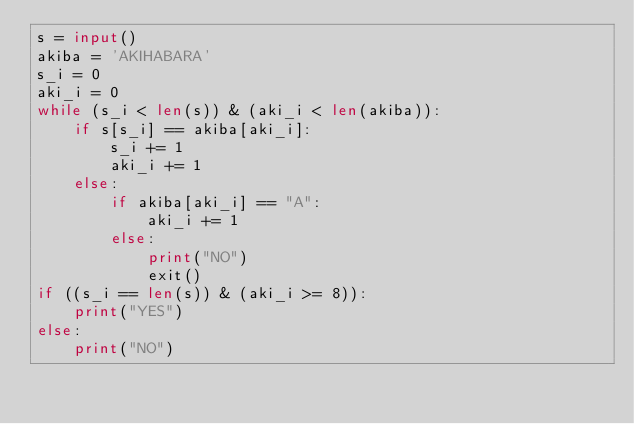Convert code to text. <code><loc_0><loc_0><loc_500><loc_500><_Python_>s = input()
akiba = 'AKIHABARA'
s_i = 0
aki_i = 0
while (s_i < len(s)) & (aki_i < len(akiba)):
    if s[s_i] == akiba[aki_i]:
        s_i += 1
        aki_i += 1
    else:
        if akiba[aki_i] == "A":
            aki_i += 1
        else:
            print("NO")
            exit()
if ((s_i == len(s)) & (aki_i >= 8)):
    print("YES")
else:
    print("NO")</code> 